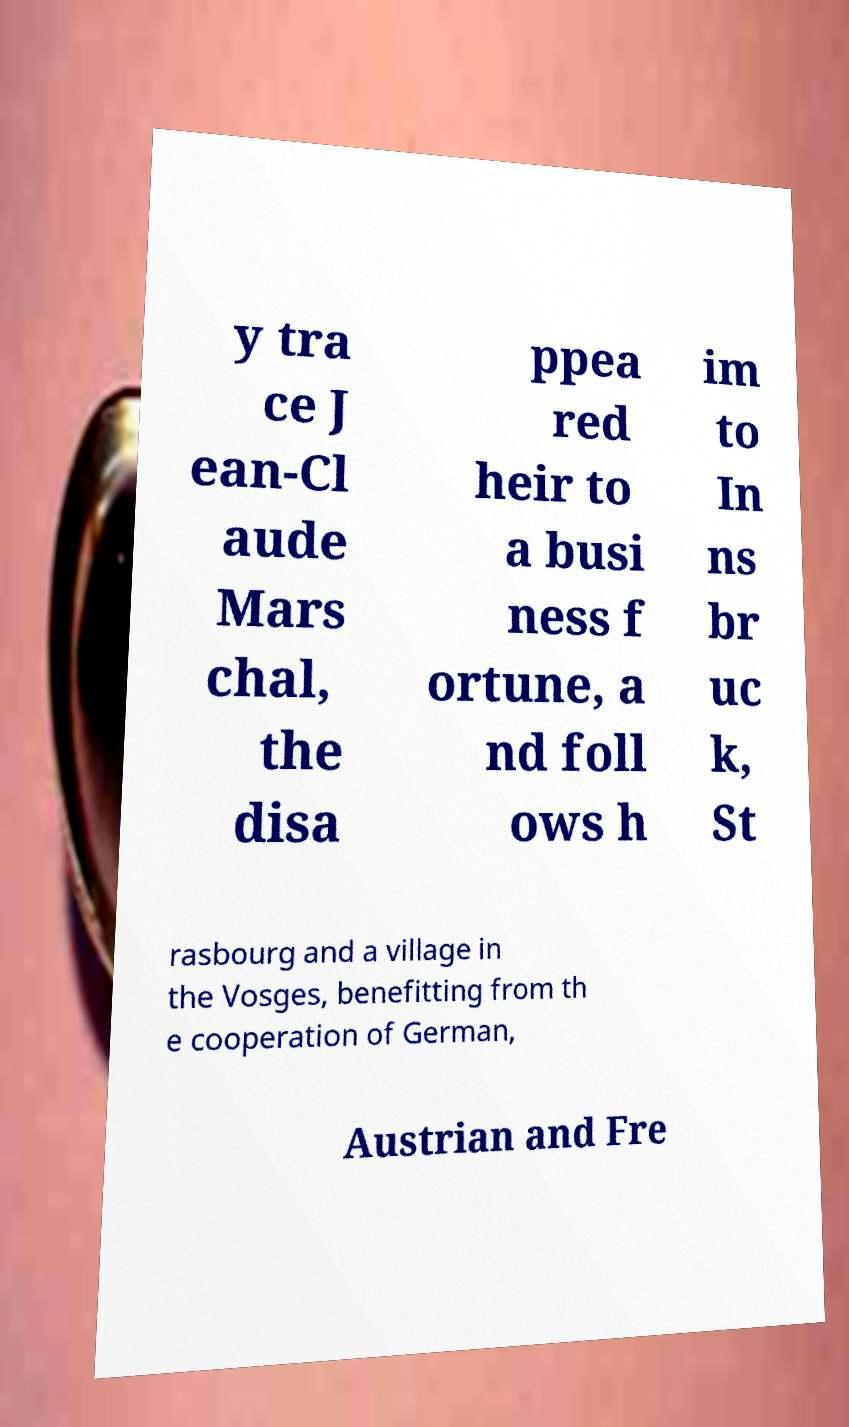What messages or text are displayed in this image? I need them in a readable, typed format. y tra ce J ean-Cl aude Mars chal, the disa ppea red heir to a busi ness f ortune, a nd foll ows h im to In ns br uc k, St rasbourg and a village in the Vosges, benefitting from th e cooperation of German, Austrian and Fre 